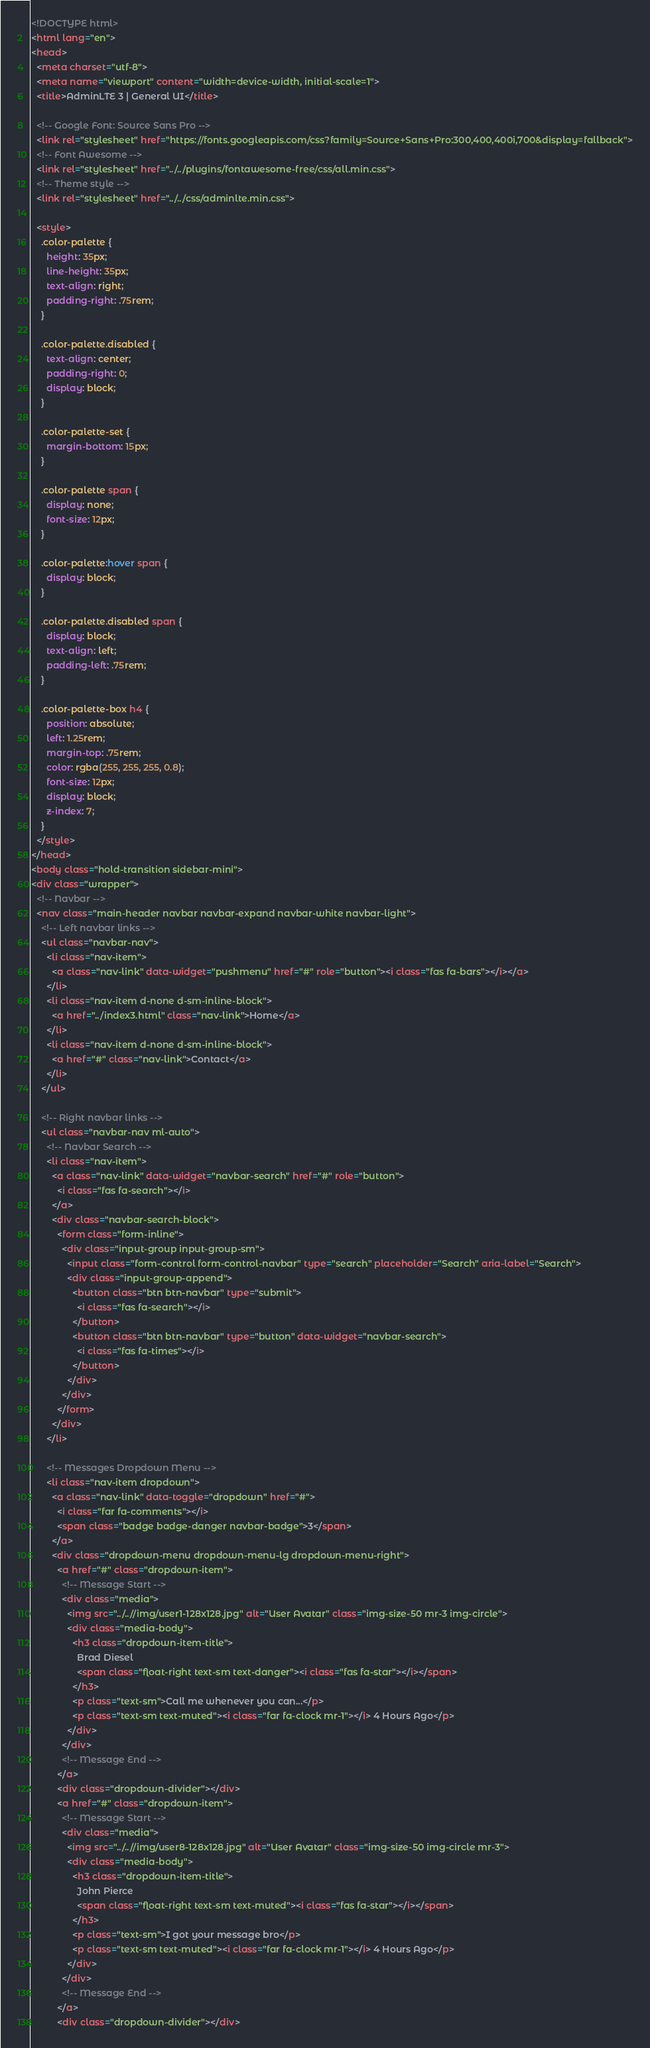Convert code to text. <code><loc_0><loc_0><loc_500><loc_500><_HTML_><!DOCTYPE html>
<html lang="en">
<head>
  <meta charset="utf-8">
  <meta name="viewport" content="width=device-width, initial-scale=1">
  <title>AdminLTE 3 | General UI</title>

  <!-- Google Font: Source Sans Pro -->
  <link rel="stylesheet" href="https://fonts.googleapis.com/css?family=Source+Sans+Pro:300,400,400i,700&display=fallback">
  <!-- Font Awesome -->
  <link rel="stylesheet" href="../../plugins/fontawesome-free/css/all.min.css">
  <!-- Theme style -->
  <link rel="stylesheet" href="../../css/adminlte.min.css">

  <style>
    .color-palette {
      height: 35px;
      line-height: 35px;
      text-align: right;
      padding-right: .75rem;
    }

    .color-palette.disabled {
      text-align: center;
      padding-right: 0;
      display: block;
    }

    .color-palette-set {
      margin-bottom: 15px;
    }

    .color-palette span {
      display: none;
      font-size: 12px;
    }

    .color-palette:hover span {
      display: block;
    }

    .color-palette.disabled span {
      display: block;
      text-align: left;
      padding-left: .75rem;
    }

    .color-palette-box h4 {
      position: absolute;
      left: 1.25rem;
      margin-top: .75rem;
      color: rgba(255, 255, 255, 0.8);
      font-size: 12px;
      display: block;
      z-index: 7;
    }
  </style>
</head>
<body class="hold-transition sidebar-mini">
<div class="wrapper">
  <!-- Navbar -->
  <nav class="main-header navbar navbar-expand navbar-white navbar-light">
    <!-- Left navbar links -->
    <ul class="navbar-nav">
      <li class="nav-item">
        <a class="nav-link" data-widget="pushmenu" href="#" role="button"><i class="fas fa-bars"></i></a>
      </li>
      <li class="nav-item d-none d-sm-inline-block">
        <a href="../index3.html" class="nav-link">Home</a>
      </li>
      <li class="nav-item d-none d-sm-inline-block">
        <a href="#" class="nav-link">Contact</a>
      </li>
    </ul>

    <!-- Right navbar links -->
    <ul class="navbar-nav ml-auto">
      <!-- Navbar Search -->
      <li class="nav-item">
        <a class="nav-link" data-widget="navbar-search" href="#" role="button">
          <i class="fas fa-search"></i>
        </a>
        <div class="navbar-search-block">
          <form class="form-inline">
            <div class="input-group input-group-sm">
              <input class="form-control form-control-navbar" type="search" placeholder="Search" aria-label="Search">
              <div class="input-group-append">
                <button class="btn btn-navbar" type="submit">
                  <i class="fas fa-search"></i>
                </button>
                <button class="btn btn-navbar" type="button" data-widget="navbar-search">
                  <i class="fas fa-times"></i>
                </button>
              </div>
            </div>
          </form>
        </div>
      </li>

      <!-- Messages Dropdown Menu -->
      <li class="nav-item dropdown">
        <a class="nav-link" data-toggle="dropdown" href="#">
          <i class="far fa-comments"></i>
          <span class="badge badge-danger navbar-badge">3</span>
        </a>
        <div class="dropdown-menu dropdown-menu-lg dropdown-menu-right">
          <a href="#" class="dropdown-item">
            <!-- Message Start -->
            <div class="media">
              <img src="../..//img/user1-128x128.jpg" alt="User Avatar" class="img-size-50 mr-3 img-circle">
              <div class="media-body">
                <h3 class="dropdown-item-title">
                  Brad Diesel
                  <span class="float-right text-sm text-danger"><i class="fas fa-star"></i></span>
                </h3>
                <p class="text-sm">Call me whenever you can...</p>
                <p class="text-sm text-muted"><i class="far fa-clock mr-1"></i> 4 Hours Ago</p>
              </div>
            </div>
            <!-- Message End -->
          </a>
          <div class="dropdown-divider"></div>
          <a href="#" class="dropdown-item">
            <!-- Message Start -->
            <div class="media">
              <img src="../..//img/user8-128x128.jpg" alt="User Avatar" class="img-size-50 img-circle mr-3">
              <div class="media-body">
                <h3 class="dropdown-item-title">
                  John Pierce
                  <span class="float-right text-sm text-muted"><i class="fas fa-star"></i></span>
                </h3>
                <p class="text-sm">I got your message bro</p>
                <p class="text-sm text-muted"><i class="far fa-clock mr-1"></i> 4 Hours Ago</p>
              </div>
            </div>
            <!-- Message End -->
          </a>
          <div class="dropdown-divider"></div></code> 